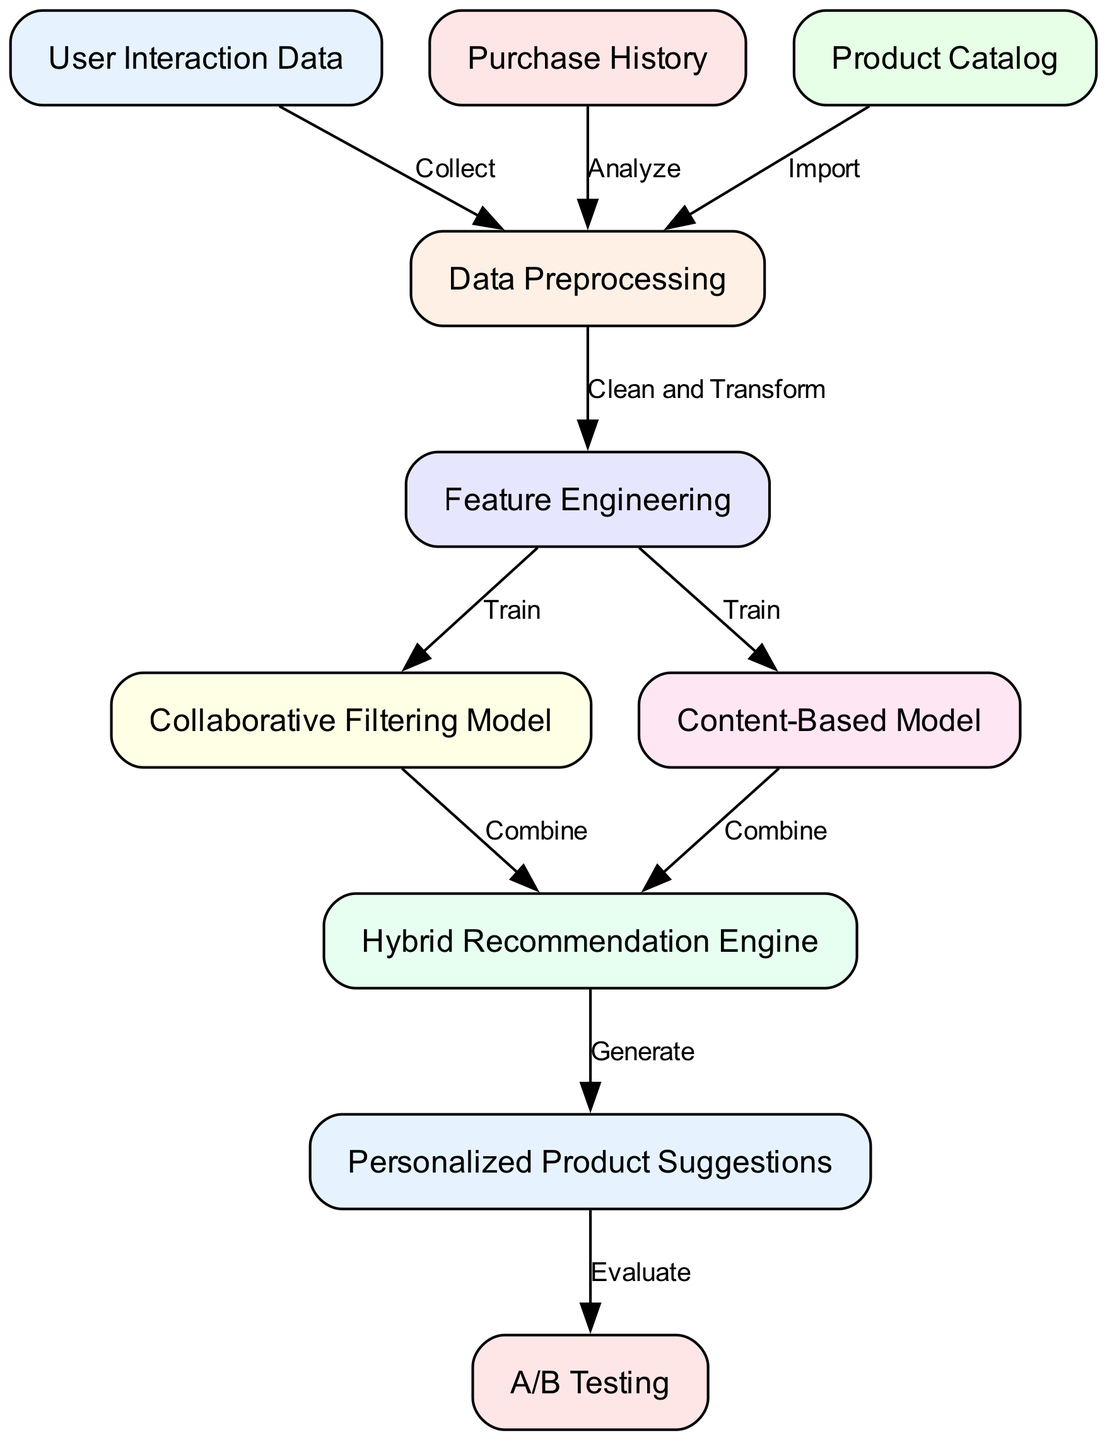What is the starting point of the flowchart? The starting point is labeled "User Interaction Data," which is the first node in the flowchart. This indicates that the flow begins with data related to how users interact with the system.
Answer: User Interaction Data How many edges are in the diagram? To determine the number of edges, we count the connections made between nodes. Based on the data provided, there are a total of 10 edges in the diagram.
Answer: 10 What are the two models trained after Feature Engineering? After Feature Engineering, two models are trained: the "Collaborative Filtering Model" and the "Content-Based Model." These are the next steps in the flowchart after feature engineering is completed.
Answer: Collaborative Filtering Model and Content-Based Model What is the final output in the recommendation system flowchart? The final output in the diagram is "Personalized Product Suggestions," which is the result of the processes outlined in the flowchart leading up to generating these suggestions for users.
Answer: Personalized Product Suggestions Which node follows Data Preprocessing? Following "Data Preprocessing," the next step in the flowchart is "Feature Engineering." This indicates that after preprocessing the data, the system will engineer relevant features for modeling.
Answer: Feature Engineering What is the purpose of A/B Testing in this diagram? A/B Testing serves the purpose of evaluating the effectiveness of the "Personalized Product Suggestions" generated by the recommendation engine, helping to assess which version is more successful.
Answer: Evaluate What connects the "Collaborative Filtering Model" and "Content-Based Model" to the "Hybrid Recommendation Engine"? Both the "Collaborative Filtering Model" and "Content-Based Model" connect to the "Hybrid Recommendation Engine" through the "Combine" relationship, indicating that these two models are integrated to generate better product suggestions.
Answer: Combine What action is taken after generating personalized product suggestions? After generating personalized product suggestions, the action taken is "A/B Testing," which evaluates the performance of these suggestions in the recommendation system.
Answer: Evaluate 